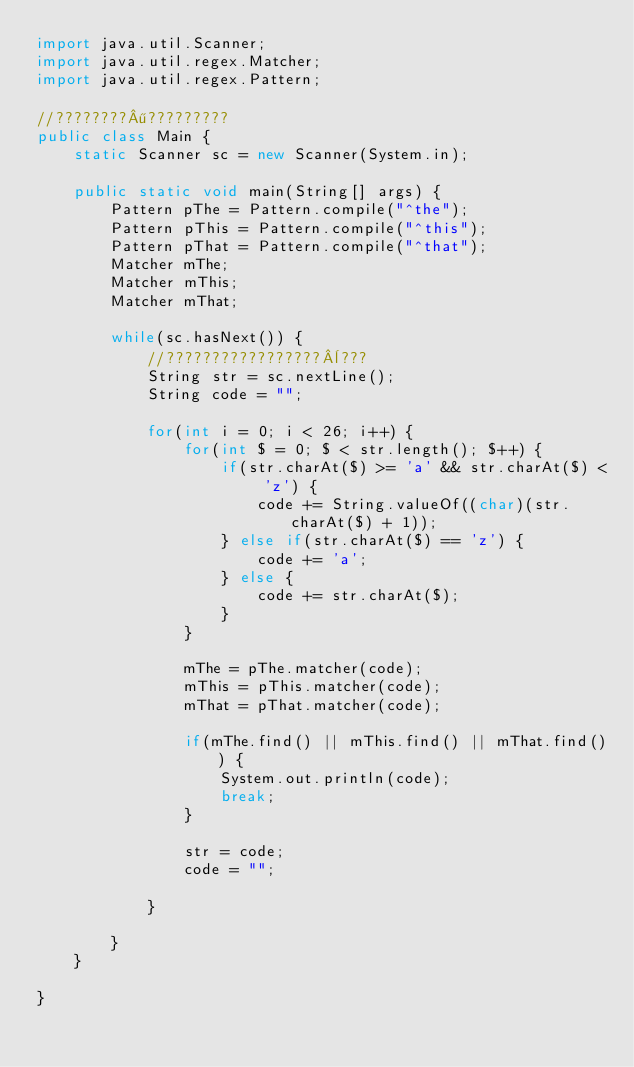<code> <loc_0><loc_0><loc_500><loc_500><_Java_>import java.util.Scanner;
import java.util.regex.Matcher;
import java.util.regex.Pattern;

//????????¶?????????
public class Main {
	static Scanner sc = new Scanner(System.in);

	public static void main(String[] args) {
		Pattern pThe = Pattern.compile("^the");
		Pattern pThis = Pattern.compile("^this");
		Pattern pThat = Pattern.compile("^that");
		Matcher mThe;
		Matcher mThis;
		Matcher mThat;

		while(sc.hasNext()) {
			//?????????????????¨???
			String str = sc.nextLine();
			String code = "";

			for(int i = 0; i < 26; i++) {
				for(int $ = 0; $ < str.length(); $++) {
					if(str.charAt($) >= 'a' && str.charAt($) < 'z') {
						code += String.valueOf((char)(str.charAt($) + 1));
					} else if(str.charAt($) == 'z') {
						code += 'a';
					} else {
						code += str.charAt($);
					}
				}

				mThe = pThe.matcher(code);
				mThis = pThis.matcher(code);
				mThat = pThat.matcher(code);

				if(mThe.find() || mThis.find() || mThat.find()) {
					System.out.println(code);
					break;
				}

				str = code;
				code = "";

			}

		}
	}

}</code> 